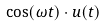<formula> <loc_0><loc_0><loc_500><loc_500>\cos ( \omega t ) \cdot u ( t )</formula> 